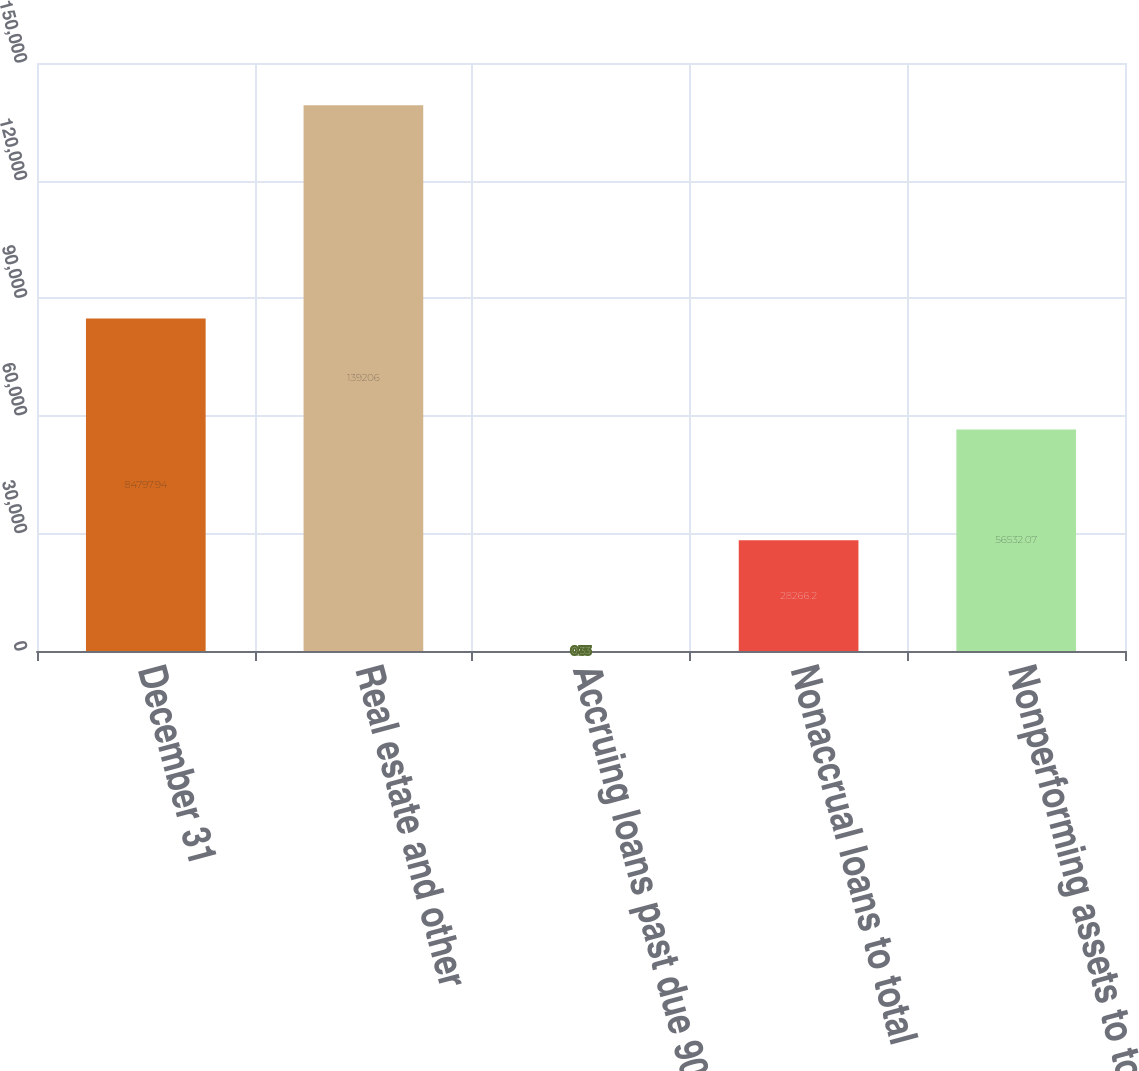Convert chart. <chart><loc_0><loc_0><loc_500><loc_500><bar_chart><fcel>December 31<fcel>Real estate and other<fcel>Accruing loans past due 90<fcel>Nonaccrual loans to total<fcel>Nonperforming assets to total<nl><fcel>84797.9<fcel>139206<fcel>0.33<fcel>28266.2<fcel>56532.1<nl></chart> 